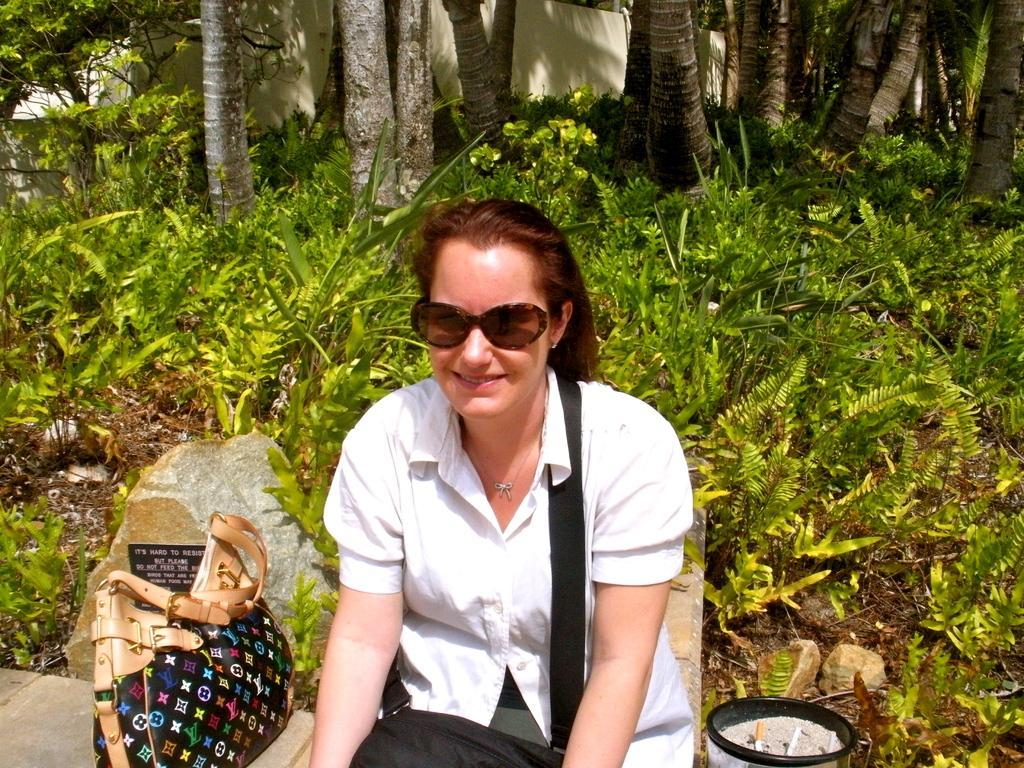Please provide a concise description of this image. In this image in the foreground there is one woman who is sitting, beside her there is one bag. In the background there are some plants and trees and wall. 